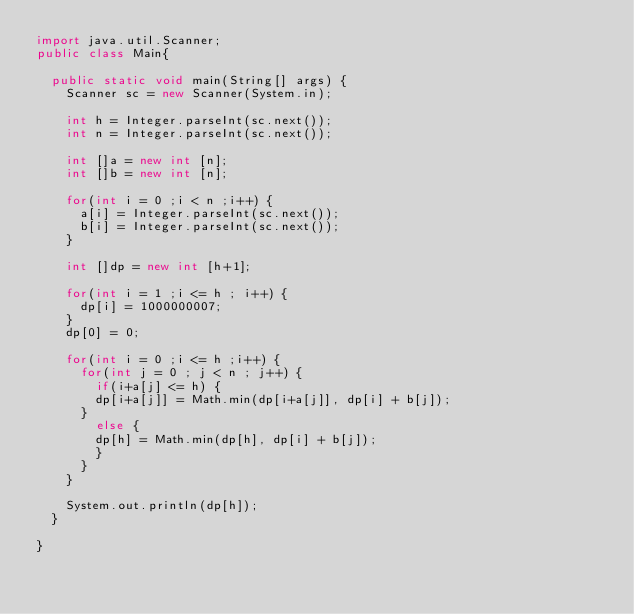<code> <loc_0><loc_0><loc_500><loc_500><_Java_>import java.util.Scanner;
public class Main{

	public static void main(String[] args) {
		Scanner sc = new Scanner(System.in);
		
		int h = Integer.parseInt(sc.next());
		int n = Integer.parseInt(sc.next());
		
		int []a = new int [n];
		int []b = new int [n];
		
		for(int i = 0 ;i < n ;i++) {
			a[i] = Integer.parseInt(sc.next());
			b[i] = Integer.parseInt(sc.next());
		}

		int []dp = new int [h+1];
		
		for(int i = 1 ;i <= h ; i++) {
			dp[i] = 1000000007;
		}
		dp[0] = 0;
		
		for(int i = 0 ;i <= h ;i++) {
			for(int j = 0 ; j < n ; j++) {
				if(i+a[j] <= h) {
				dp[i+a[j]] = Math.min(dp[i+a[j]], dp[i] + b[j]);
			}
				else {
				dp[h] = Math.min(dp[h], dp[i] + b[j]);
				}
			}
		}
		
		System.out.println(dp[h]);
	}

}
</code> 